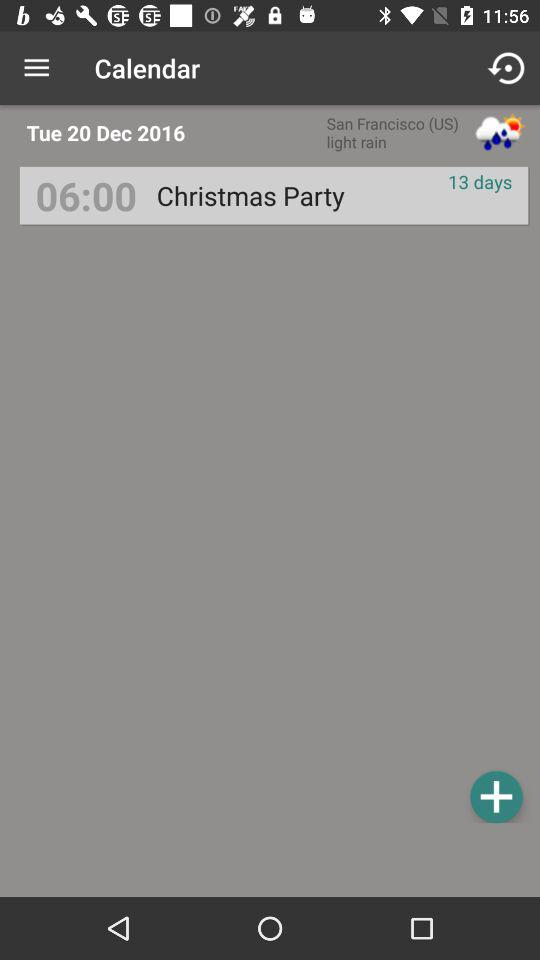How many days are left until the "Christmas party"? There are 13 days left until the "Christmas party". 